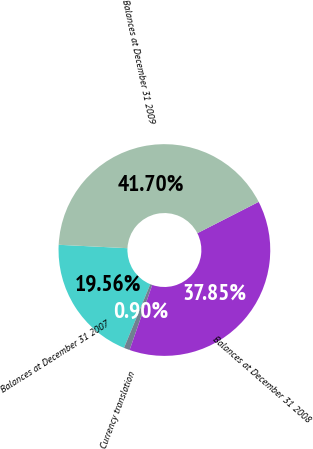Convert chart. <chart><loc_0><loc_0><loc_500><loc_500><pie_chart><fcel>Balances at December 31 2007<fcel>Currency translation<fcel>Balances at December 31 2008<fcel>Balances at December 31 2009<nl><fcel>19.56%<fcel>0.9%<fcel>37.85%<fcel>41.7%<nl></chart> 